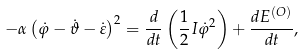Convert formula to latex. <formula><loc_0><loc_0><loc_500><loc_500>- \alpha \left ( \dot { \varphi } - \dot { \vartheta } - \dot { \varepsilon } \right ) ^ { 2 } = \frac { d } { d t } \left ( \frac { 1 } { 2 } I \dot { \varphi } ^ { 2 } \right ) + \frac { d E ^ { ( O ) } } { d t } ,</formula> 